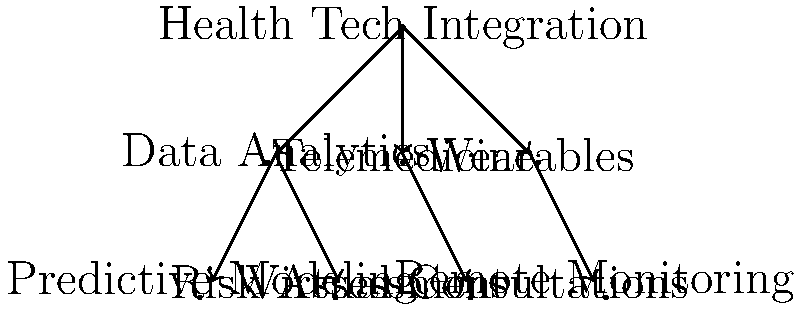In the hierarchical structure of a health insurance company's technology integration plan, which component directly connects to both "Predictive Modeling" and "Risk Assessment"? To answer this question, we need to analyze the hierarchical structure presented in the diagram:

1. The top-level component is "Health Tech Integration".
2. Under "Health Tech Integration", there are three main branches:
   a. Data Analytics
   b. Telemedicine
   c. Wearables
3. "Data Analytics" further branches into two sub-components:
   a. Predictive Modeling
   b. Risk Assessment
4. "Telemedicine" branches into "Virtual Consultations"
5. "Wearables" branches into "Remote Monitoring"

By examining the connections, we can see that both "Predictive Modeling" and "Risk Assessment" are directly connected to "Data Analytics". This makes "Data Analytics" the component that directly connects to both of these sub-components in the hierarchical structure.
Answer: Data Analytics 